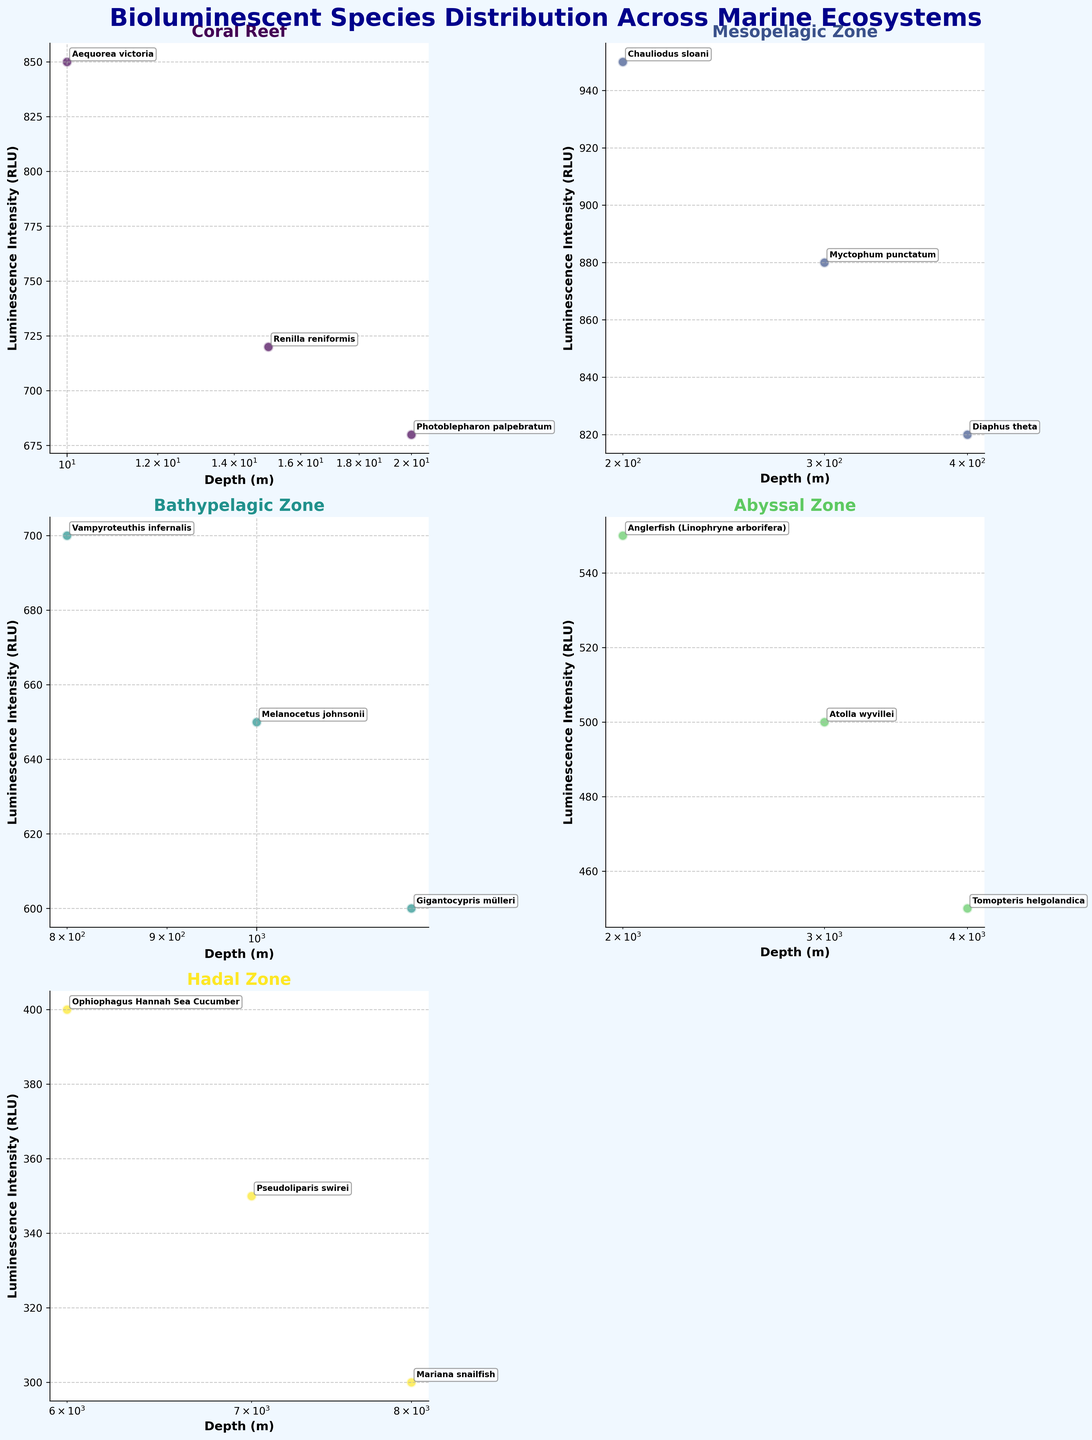What's the title of the figure? The title is typically located at the top of a figure and is often the most prominent text. In this case, it reads "Bioluminescent Species Distribution Across Marine Ecosystems".
Answer: Bioluminescent Species Distribution Across Marine Ecosystems How many different ecosystems are featured in the plots? To determine the number of ecosystems, look at the titles of each subplot. Each unique title represents a different ecosystem. The titles include Coral Reef, Mesopelagic Zone, Bathypelagic Zone, Abyssal Zone, and Hadal Zone, totaling 5 distinct ecosystems.
Answer: 5 Which species in the Coral Reef ecosystem has the highest luminescence intensity? Find the Coral Reef subplot and identify the data points. Each point is annotated with the species name. The species with the highest luminescence intensity (y-axis value) is Aequorea victoria.
Answer: Aequorea victoria At what depth is Chauliodus sloani found in the Mesopelagic Zone? Locate the Mesopelagic Zone subplot. Identify the point associated with Chauliodus sloani, which is marked on the graph. The depth corresponding to this point is 200 meters, as labeled.
Answer: 200 meters Compare the luminescence intensity of Melanocetus johnsonii and Gigantocypris mülleri in the Bathypelagic Zone. Which has a higher value, and by how much? In the Bathypelagic Zone subplot, locate the points for Melanocetus johnsonii and Gigantocypris mülleri. Melanocetus johnsonii has an intensity of 650, while Gigantocypris mülleri has an intensity of 600. Subtracting these gives a difference of 50.
Answer: Melanocetus johnsonii by 50 RLU What is the deepest species recorded in the Hadal Zone? Look at the Hadal Zone subplot to see the depths of the points plotted. The deepest point corresponds to the Mariana snailfish, found at 8000 meters.
Answer: Mariana snailfish In the Abyssal Zone, which species has the lowest luminescence intensity and what is that intensity? Check the Abyssal Zone subplot and identify the lowest point on the y-axis, annotated with the species name Tomopteris helgolandica, which has an intensity of 450.
Answer: Tomopteris helgolandica with 450 RLU Calculate the average depth of species in the Mesopelagic Zone. In the Mesopelagic Zone subplot, note the depths listed: 200, 300, and 400 meters. Sum these depths (200 + 300 + 400 = 900) and divide by the number of species (3). The average depth is 900/3 = 300 meters.
Answer: 300 meters Which ecosystem has species distributed at logarithmic depth intervals and what do we observe about the luminescence intensities across these intervals? Examining all subplots, the Hadal Zone shows species depths spaced at logarithmic intervals (6000, 7000, 8000 meters). Luminescence intensities generally decrease as depth increases, evidenced by plotting along a declining trend line on the y-axis.
Answer: Hadal Zone; intensities decrease with depth What is the range of luminescence intensities in the Mesopelagic Zone? Determine the highest and lowest luminescence intensity values in the Mesopelagic Zone subplot. The highest is 950 (Chauliodus sloani) and the lowest is 820 (Diaphus theta). The range is found by subtracting: 950 - 820 = 130.
Answer: 130 RLU 